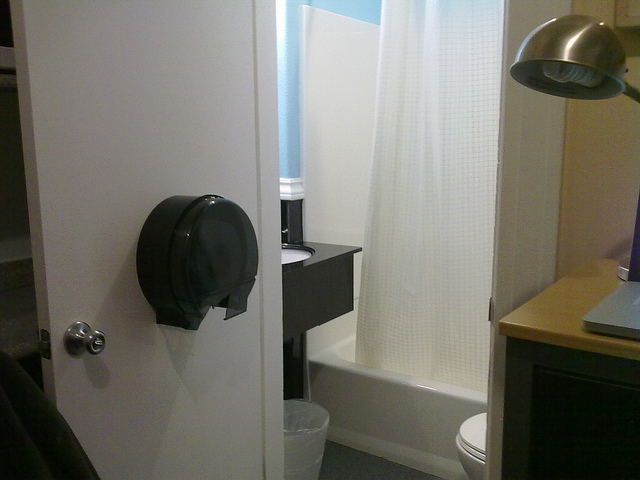<image>What is hanging on the wall outside the bathroom? It is ambiguous what is hanging on the wall outside the bathroom. It could be a towel dispenser, picture, lamp, toilet paper, or shelf. What is hanging on the wall outside the bathroom? I don't know what is hanging on the wall outside the bathroom. It can be a towel dispenser, a picture, a lamp, toilet paper, a shelf, or nothing. 